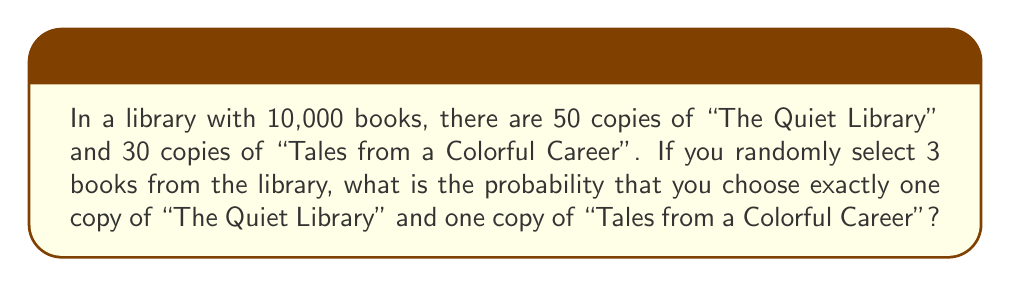Provide a solution to this math problem. Let's approach this step-by-step:

1) First, we need to calculate the number of ways to select 3 books that include exactly one copy of each specified book and one other book.

   a) Choose 1 copy of "The Quiet Library": $\binom{50}{1}$ ways
   b) Choose 1 copy of "Tales from a Colorful Career": $\binom{30}{1}$ ways
   c) Choose 1 book from the remaining books: $\binom{10000-50-30}{1} = \binom{9920}{1}$ ways

2) The total number of ways to select these books is:

   $50 \times 30 \times 9920 = 14,880,000$

3) Now, we need to calculate the total number of ways to select any 3 books from 10,000 books:

   $\binom{10000}{3} = \frac{10000!}{3!(10000-3)!} = \frac{10000 \times 9999 \times 9998}{6} = 166,616,670,000$

4) The probability is the number of favorable outcomes divided by the total number of possible outcomes:

   $P = \frac{14,880,000}{166,616,670,000} = \frac{744}{8,330,833} \approx 0.0000893$

Therefore, the probability is $\frac{744}{8,330,833}$ or approximately 0.0089%.
Answer: $\frac{744}{8,330,833}$ 